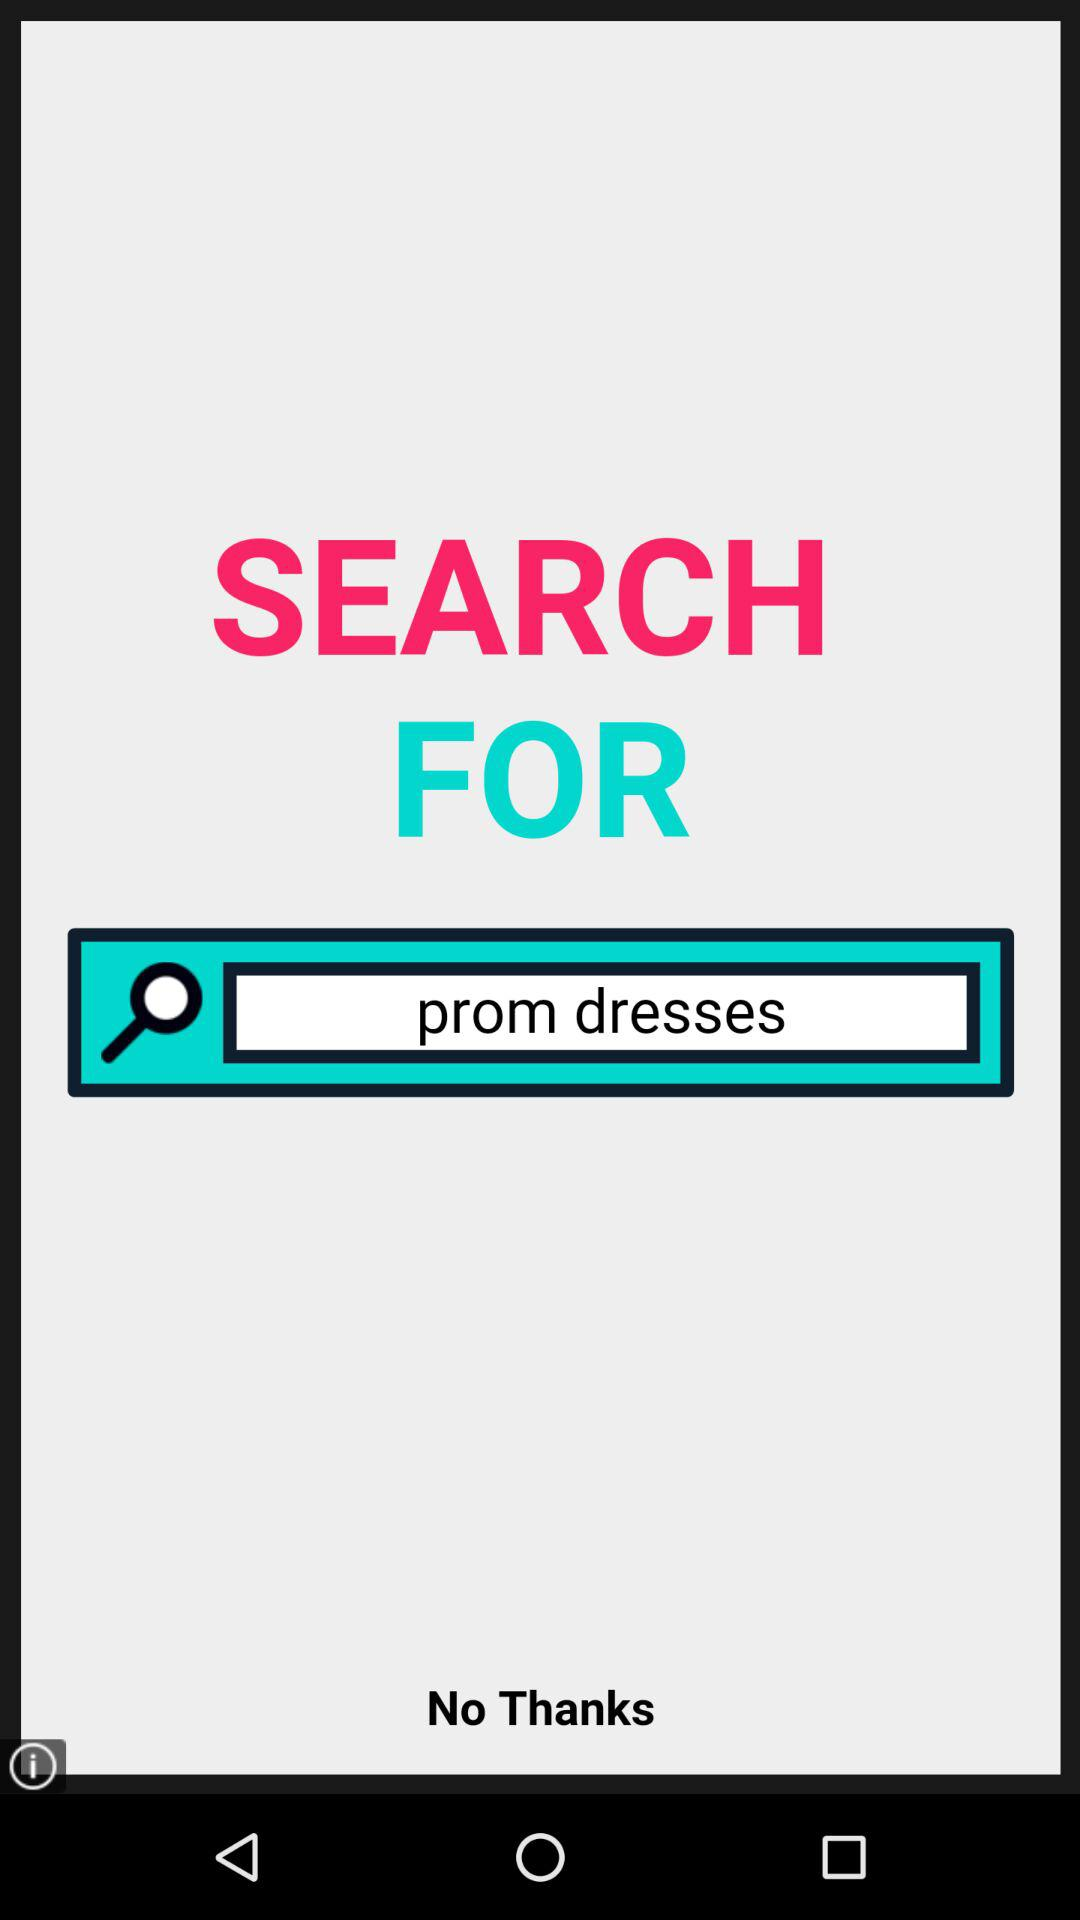What is the text entered in the search bar? The text entered in the search bar is "prom dresses". 